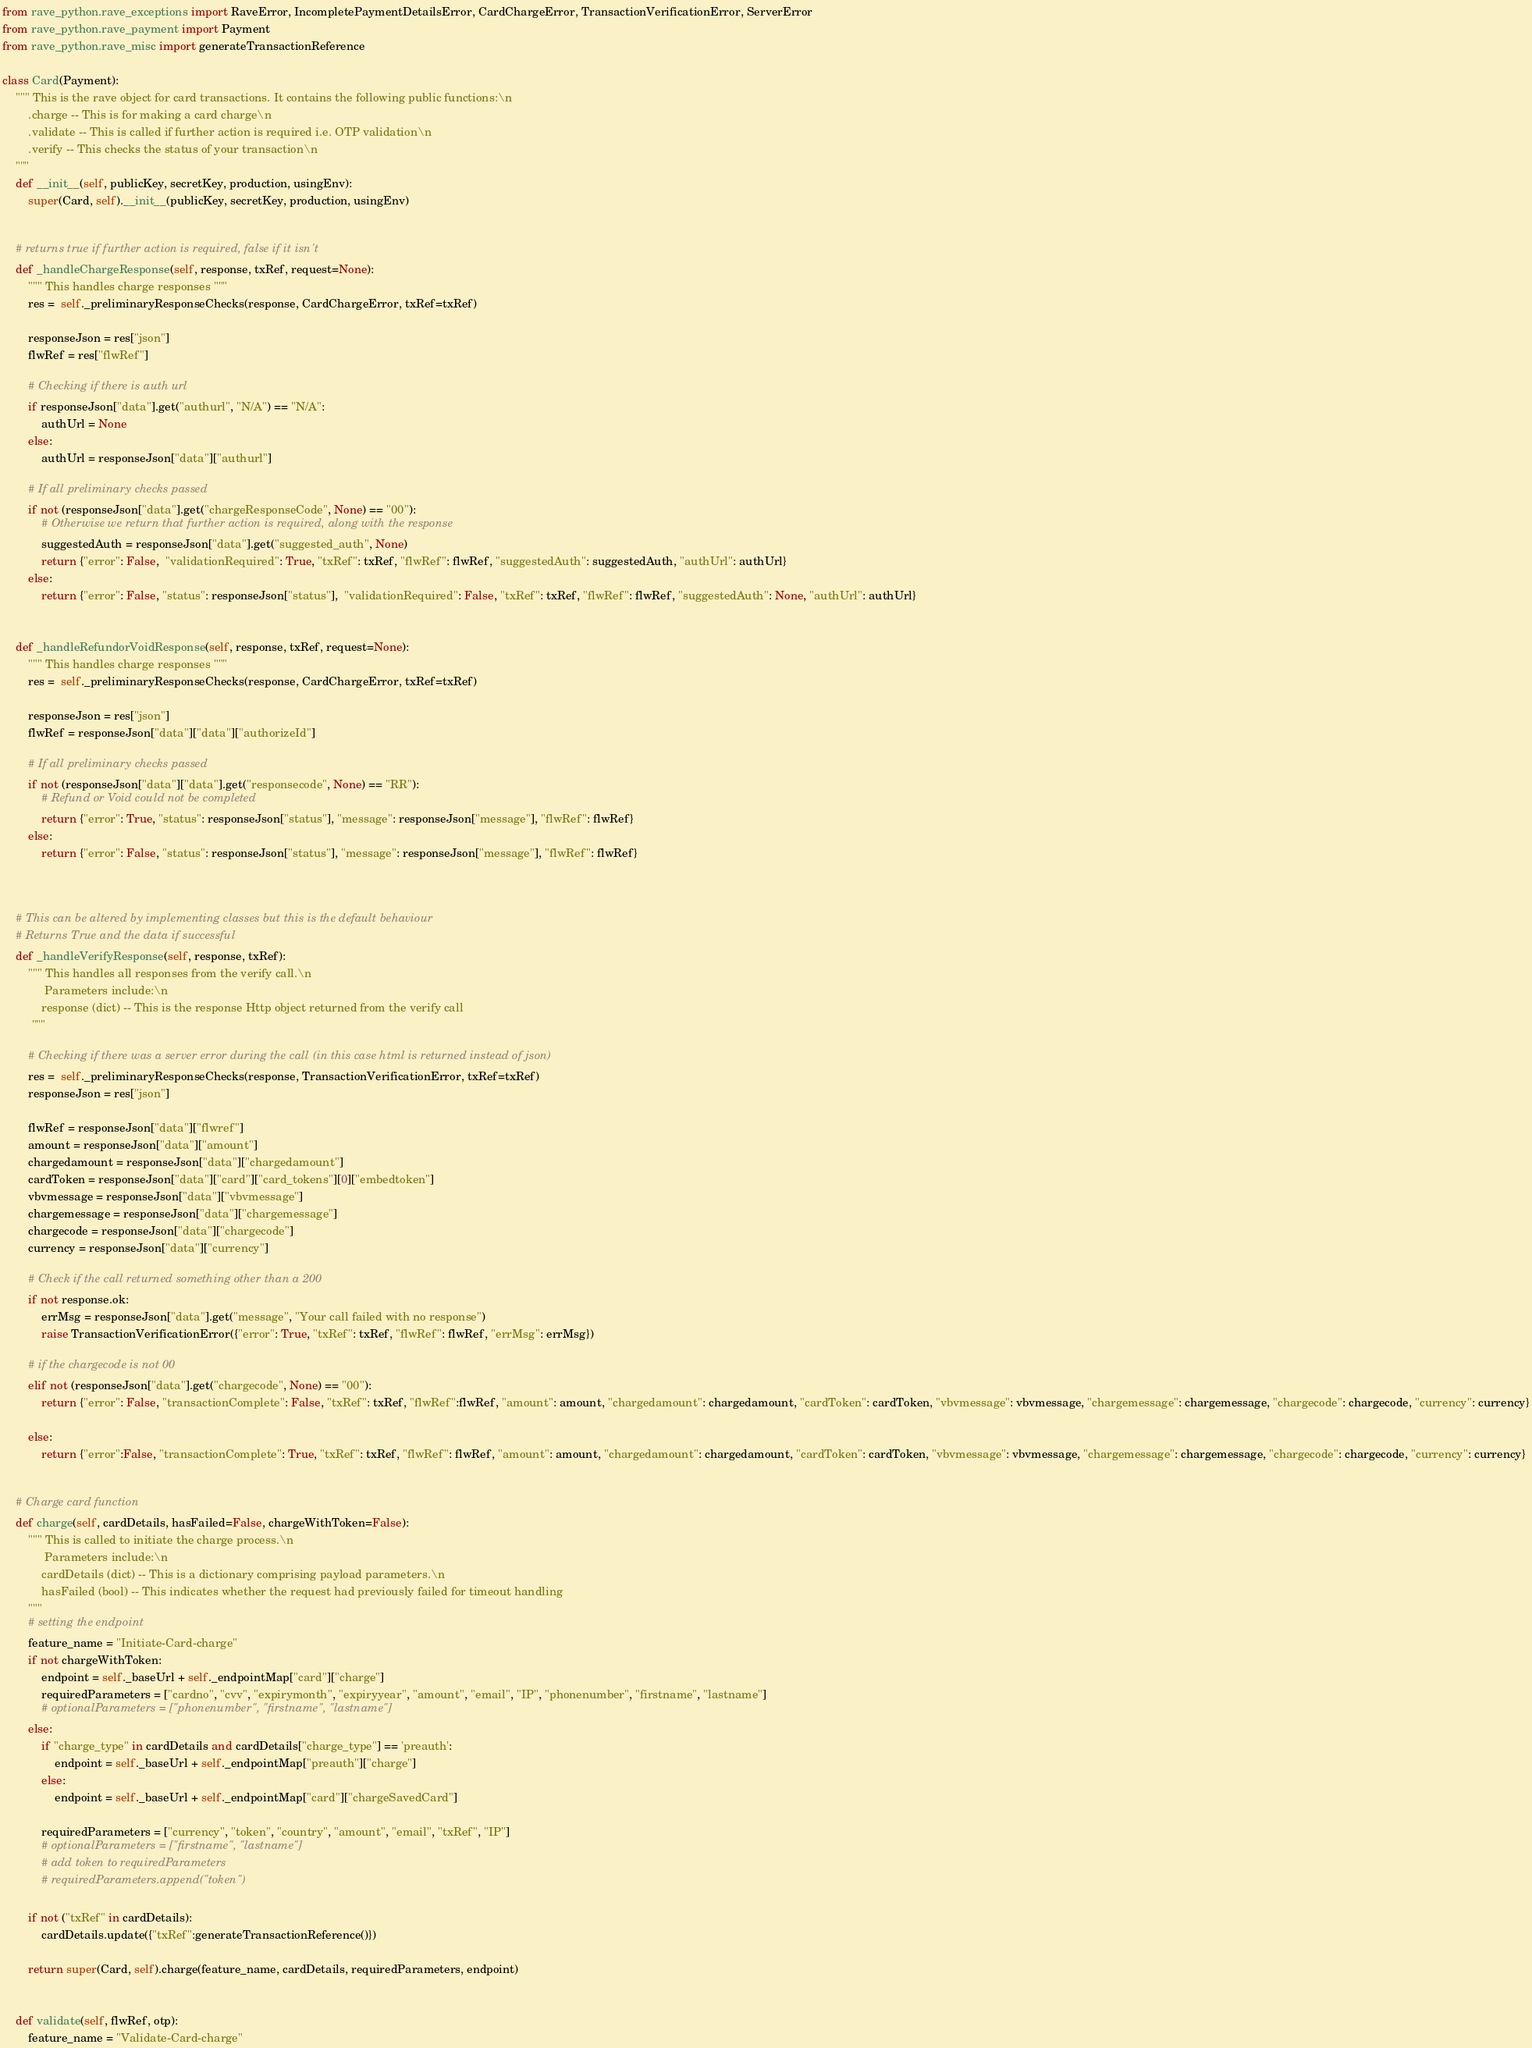<code> <loc_0><loc_0><loc_500><loc_500><_Python_>from rave_python.rave_exceptions import RaveError, IncompletePaymentDetailsError, CardChargeError, TransactionVerificationError, ServerError
from rave_python.rave_payment import Payment
from rave_python.rave_misc import generateTransactionReference

class Card(Payment):
    """ This is the rave object for card transactions. It contains the following public functions:\n
        .charge -- This is for making a card charge\n
        .validate -- This is called if further action is required i.e. OTP validation\n
        .verify -- This checks the status of your transaction\n
    """
    def __init__(self, publicKey, secretKey, production, usingEnv):
        super(Card, self).__init__(publicKey, secretKey, production, usingEnv)


    # returns true if further action is required, false if it isn't    
    def _handleChargeResponse(self, response, txRef, request=None):
        """ This handles charge responses """
        res =  self._preliminaryResponseChecks(response, CardChargeError, txRef=txRef)

        responseJson = res["json"]
        flwRef = res["flwRef"]

        # Checking if there is auth url
        if responseJson["data"].get("authurl", "N/A") == "N/A":
            authUrl = None
        else:
            authUrl = responseJson["data"]["authurl"]

        # If all preliminary checks passed
        if not (responseJson["data"].get("chargeResponseCode", None) == "00"):
            # Otherwise we return that further action is required, along with the response
            suggestedAuth = responseJson["data"].get("suggested_auth", None)
            return {"error": False,  "validationRequired": True, "txRef": txRef, "flwRef": flwRef, "suggestedAuth": suggestedAuth, "authUrl": authUrl}
        else:
            return {"error": False, "status": responseJson["status"],  "validationRequired": False, "txRef": txRef, "flwRef": flwRef, "suggestedAuth": None, "authUrl": authUrl}

    
    def _handleRefundorVoidResponse(self, response, txRef, request=None):
        """ This handles charge responses """
        res =  self._preliminaryResponseChecks(response, CardChargeError, txRef=txRef)

        responseJson = res["json"]
        flwRef = responseJson["data"]["data"]["authorizeId"]

        # If all preliminary checks passed
        if not (responseJson["data"]["data"].get("responsecode", None) == "RR"):
            # Refund or Void could not be completed
            return {"error": True, "status": responseJson["status"], "message": responseJson["message"], "flwRef": flwRef}
        else:
            return {"error": False, "status": responseJson["status"], "message": responseJson["message"], "flwRef": flwRef}

    

    # This can be altered by implementing classes but this is the default behaviour
    # Returns True and the data if successful
    def _handleVerifyResponse(self, response, txRef):
        """ This handles all responses from the verify call.\n
             Parameters include:\n
            response (dict) -- This is the response Http object returned from the verify call
         """

        # Checking if there was a server error during the call (in this case html is returned instead of json)
        res =  self._preliminaryResponseChecks(response, TransactionVerificationError, txRef=txRef)
        responseJson = res["json"]

        flwRef = responseJson["data"]["flwref"]
        amount = responseJson["data"]["amount"]
        chargedamount = responseJson["data"]["chargedamount"]
        cardToken = responseJson["data"]["card"]["card_tokens"][0]["embedtoken"]
        vbvmessage = responseJson["data"]["vbvmessage"]
        chargemessage = responseJson["data"]["chargemessage"]
        chargecode = responseJson["data"]["chargecode"]
        currency = responseJson["data"]["currency"]
 
        # Check if the call returned something other than a 200
        if not response.ok:
            errMsg = responseJson["data"].get("message", "Your call failed with no response")
            raise TransactionVerificationError({"error": True, "txRef": txRef, "flwRef": flwRef, "errMsg": errMsg})
        
        # if the chargecode is not 00
        elif not (responseJson["data"].get("chargecode", None) == "00"):
            return {"error": False, "transactionComplete": False, "txRef": txRef, "flwRef":flwRef, "amount": amount, "chargedamount": chargedamount, "cardToken": cardToken, "vbvmessage": vbvmessage, "chargemessage": chargemessage, "chargecode": chargecode, "currency": currency}
        
        else:
            return {"error":False, "transactionComplete": True, "txRef": txRef, "flwRef": flwRef, "amount": amount, "chargedamount": chargedamount, "cardToken": cardToken, "vbvmessage": vbvmessage, "chargemessage": chargemessage, "chargecode": chargecode, "currency": currency}

    
    # Charge card function
    def charge(self, cardDetails, hasFailed=False, chargeWithToken=False):
        """ This is called to initiate the charge process.\n
             Parameters include:\n
            cardDetails (dict) -- This is a dictionary comprising payload parameters.\n
            hasFailed (bool) -- This indicates whether the request had previously failed for timeout handling
        """
        # setting the endpoint
        feature_name = "Initiate-Card-charge"
        if not chargeWithToken:
            endpoint = self._baseUrl + self._endpointMap["card"]["charge"]
            requiredParameters = ["cardno", "cvv", "expirymonth", "expiryyear", "amount", "email", "IP", "phonenumber", "firstname", "lastname"]
            # optionalParameters = ["phonenumber", "firstname", "lastname"]
        else: 
            if "charge_type" in cardDetails and cardDetails["charge_type"] == 'preauth':
                endpoint = self._baseUrl + self._endpointMap["preauth"]["charge"]
            else: 
                endpoint = self._baseUrl + self._endpointMap["card"]["chargeSavedCard"]

            requiredParameters = ["currency", "token", "country", "amount", "email", "txRef", "IP"]
            # optionalParameters = ["firstname", "lastname"]
            # add token to requiredParameters
            # requiredParameters.append("token")

        if not ("txRef" in cardDetails):
            cardDetails.update({"txRef":generateTransactionReference()})

        return super(Card, self).charge(feature_name, cardDetails, requiredParameters, endpoint)
    

    def validate(self, flwRef, otp):
        feature_name = "Validate-Card-charge"</code> 